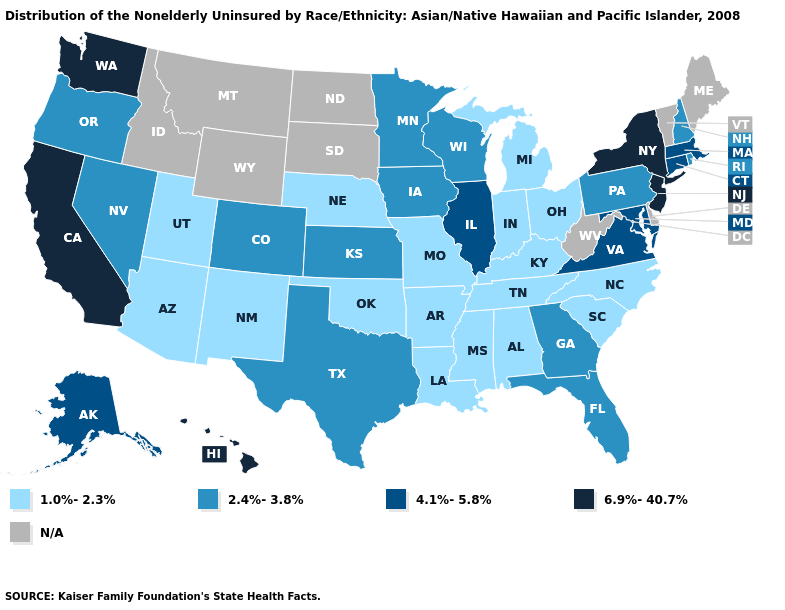What is the lowest value in the South?
Keep it brief. 1.0%-2.3%. Name the states that have a value in the range 4.1%-5.8%?
Give a very brief answer. Alaska, Connecticut, Illinois, Maryland, Massachusetts, Virginia. Name the states that have a value in the range 2.4%-3.8%?
Keep it brief. Colorado, Florida, Georgia, Iowa, Kansas, Minnesota, Nevada, New Hampshire, Oregon, Pennsylvania, Rhode Island, Texas, Wisconsin. Which states have the lowest value in the MidWest?
Write a very short answer. Indiana, Michigan, Missouri, Nebraska, Ohio. Which states hav the highest value in the South?
Write a very short answer. Maryland, Virginia. What is the highest value in the USA?
Answer briefly. 6.9%-40.7%. What is the value of Alabama?
Give a very brief answer. 1.0%-2.3%. What is the value of Nevada?
Write a very short answer. 2.4%-3.8%. What is the lowest value in states that border Nevada?
Answer briefly. 1.0%-2.3%. Which states have the lowest value in the USA?
Be succinct. Alabama, Arizona, Arkansas, Indiana, Kentucky, Louisiana, Michigan, Mississippi, Missouri, Nebraska, New Mexico, North Carolina, Ohio, Oklahoma, South Carolina, Tennessee, Utah. Name the states that have a value in the range 4.1%-5.8%?
Give a very brief answer. Alaska, Connecticut, Illinois, Maryland, Massachusetts, Virginia. Which states hav the highest value in the MidWest?
Write a very short answer. Illinois. What is the lowest value in the Northeast?
Quick response, please. 2.4%-3.8%. Name the states that have a value in the range N/A?
Concise answer only. Delaware, Idaho, Maine, Montana, North Dakota, South Dakota, Vermont, West Virginia, Wyoming. 